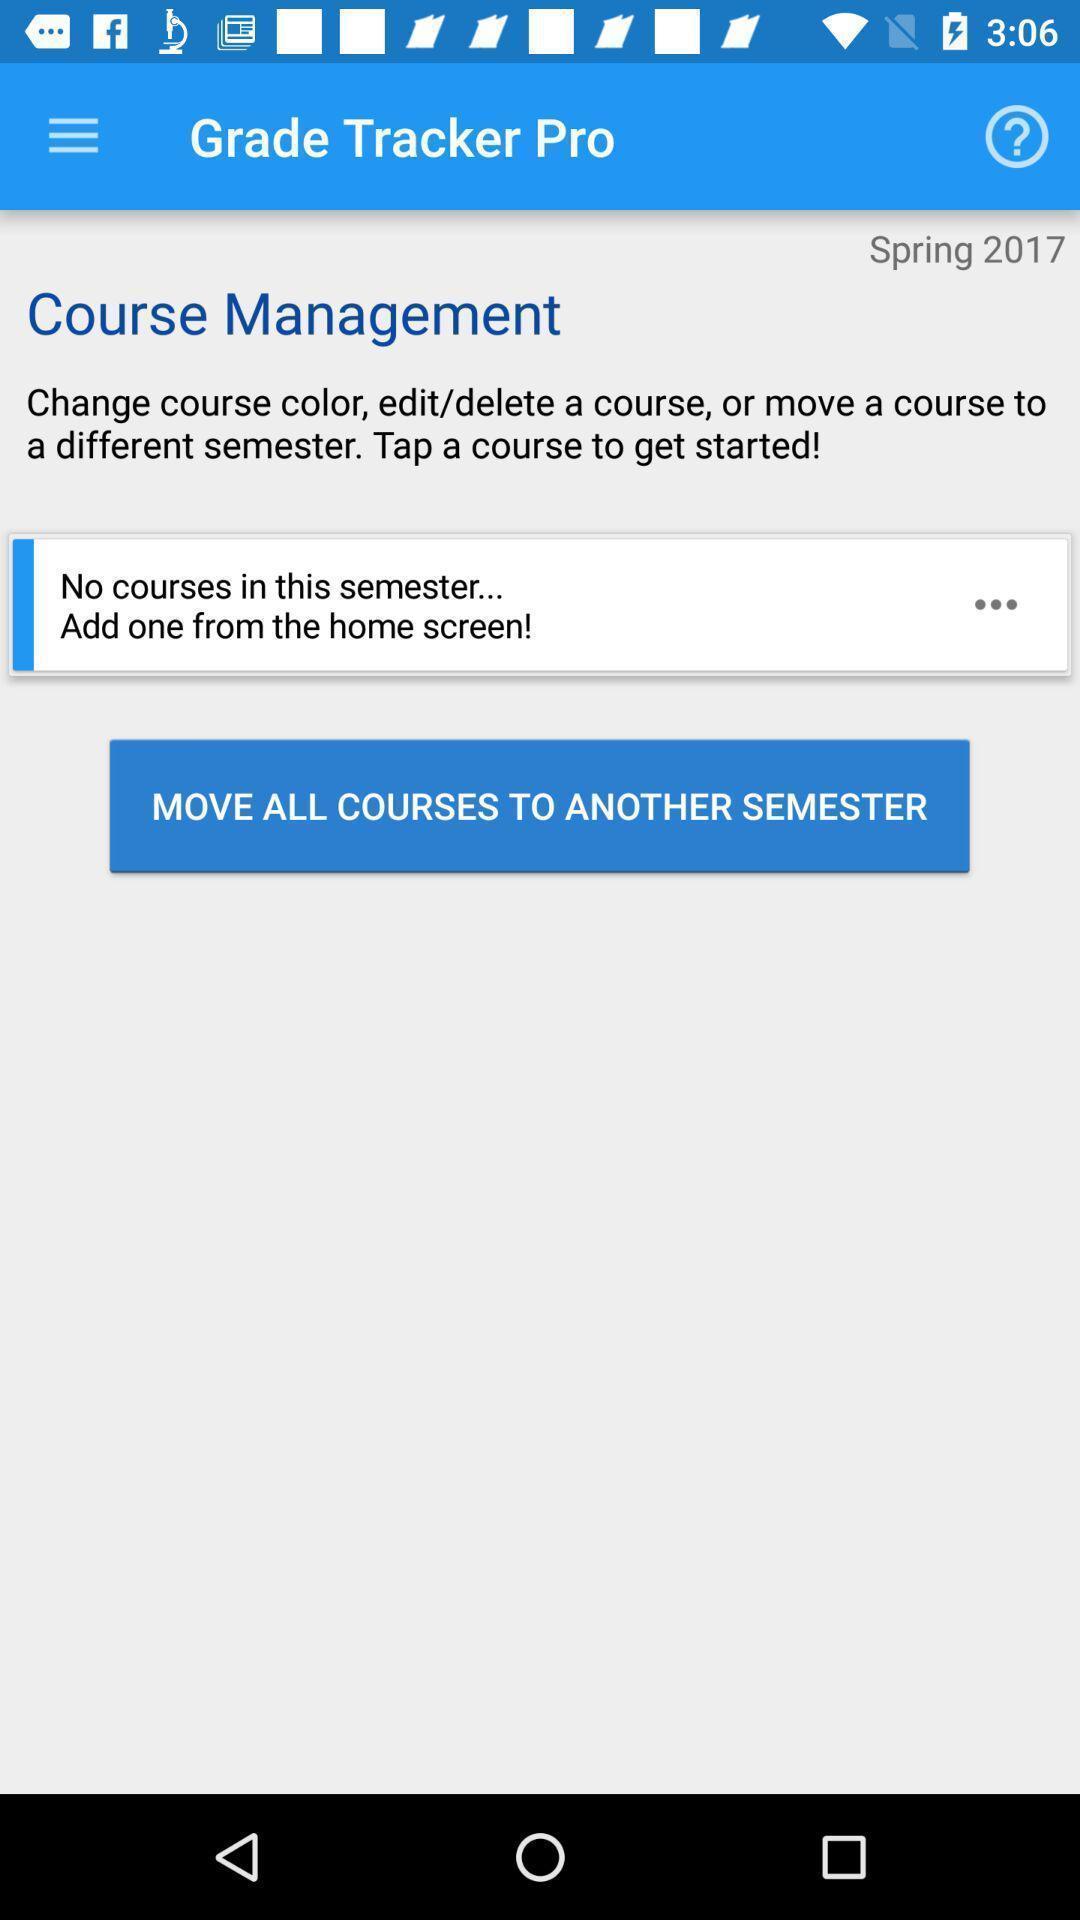Give me a narrative description of this picture. Page showing information about the course management. 